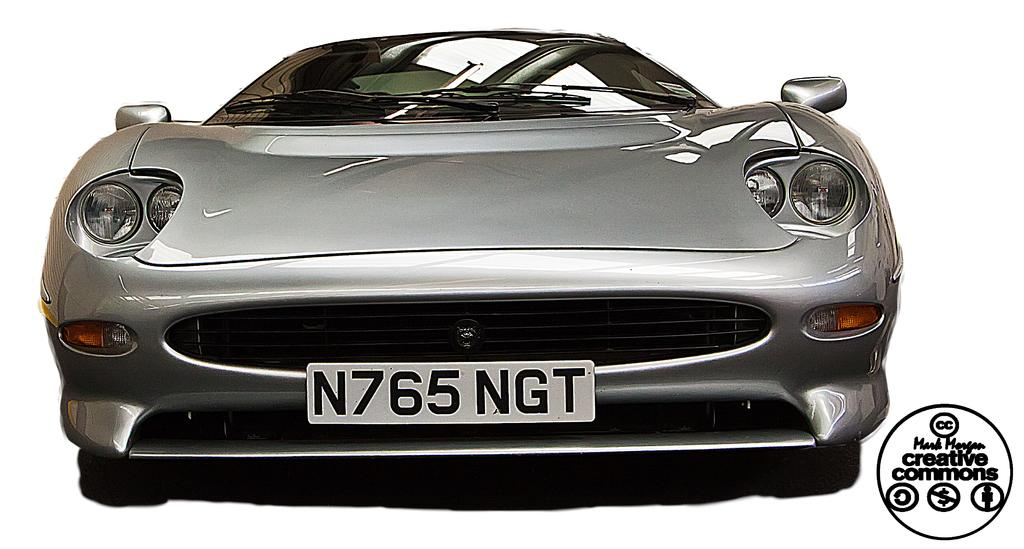What is the main subject of the image? The main subject of the image is a car. Are there any identifying features on the car? Yes, there is a name plate attached to the car. What is the color of the background in the image? The background of the image is white. Where can text be found in the image? Text is visible on the right side of the image. What type of beetle can be seen crawling on the car in the image? There is no beetle present on the car in the image. What industry is depicted in the image? The image does not depict any specific industry; it features a car with a name plate and a white background. 